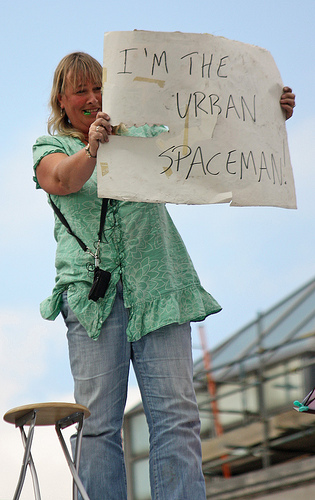<image>
Is the women on the paper? No. The women is not positioned on the paper. They may be near each other, but the women is not supported by or resting on top of the paper. Where is the sign in relation to the stool? Is it behind the stool? No. The sign is not behind the stool. From this viewpoint, the sign appears to be positioned elsewhere in the scene. Where is the person in relation to the sign? Is it in front of the sign? No. The person is not in front of the sign. The spatial positioning shows a different relationship between these objects. 